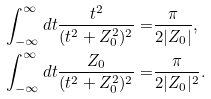Convert formula to latex. <formula><loc_0><loc_0><loc_500><loc_500>\int _ { - \infty } ^ { \infty } d t \frac { t ^ { 2 } } { ( t ^ { 2 } + Z _ { 0 } ^ { 2 } ) ^ { 2 } } = & \frac { \pi } { 2 | Z _ { 0 } | } , \\ \int _ { - \infty } ^ { \infty } d t \frac { Z _ { 0 } } { ( t ^ { 2 } + Z _ { 0 } ^ { 2 } ) ^ { 2 } } = & \frac { \pi } { 2 | Z _ { 0 } | ^ { 2 } } .</formula> 